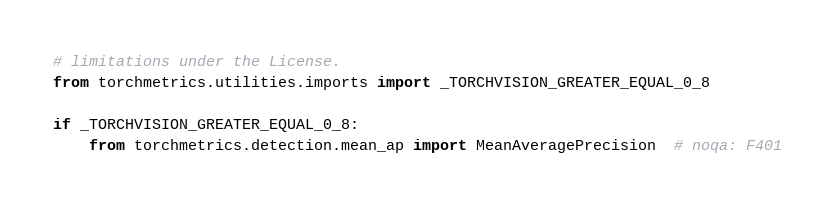Convert code to text. <code><loc_0><loc_0><loc_500><loc_500><_Python_># limitations under the License.
from torchmetrics.utilities.imports import _TORCHVISION_GREATER_EQUAL_0_8

if _TORCHVISION_GREATER_EQUAL_0_8:
    from torchmetrics.detection.mean_ap import MeanAveragePrecision  # noqa: F401
</code> 